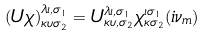Convert formula to latex. <formula><loc_0><loc_0><loc_500><loc_500>\left ( U \chi \right ) ^ { \lambda \iota , \sigma _ { 1 } } _ { \kappa \upsilon \sigma _ { 2 } } = U ^ { \lambda \iota , \sigma _ { 1 } } _ { \kappa \upsilon , \sigma _ { 2 } } \chi ^ { \iota \sigma _ { 1 } } _ { \kappa \sigma _ { 2 } } ( i \nu _ { m } ) \\</formula> 